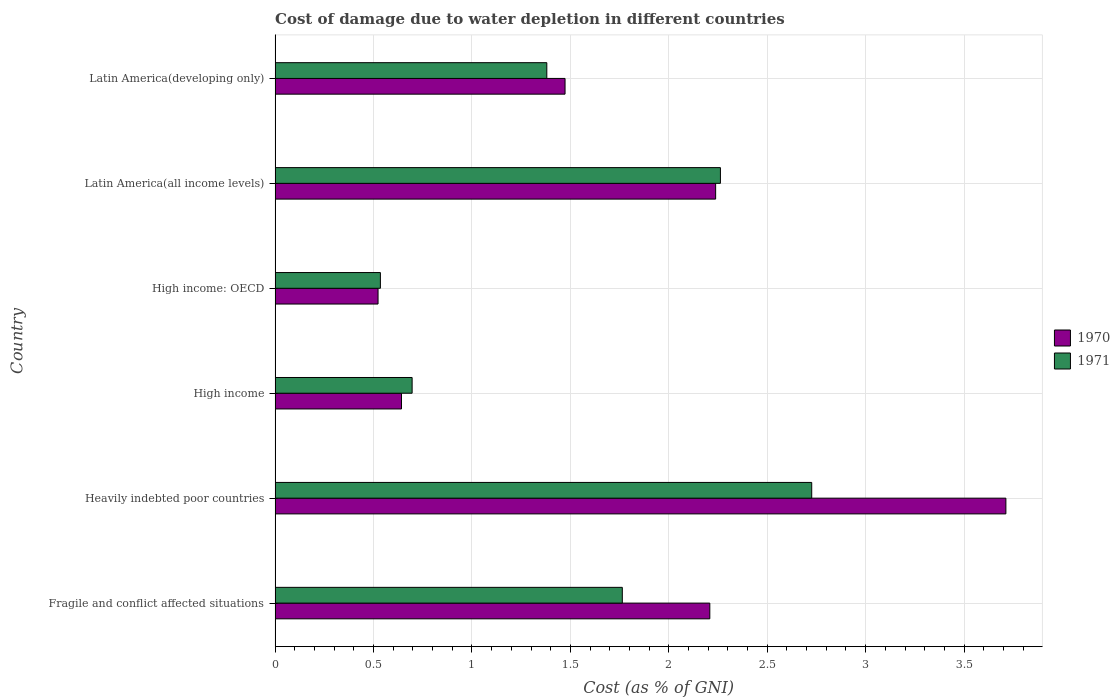How many groups of bars are there?
Make the answer very short. 6. Are the number of bars on each tick of the Y-axis equal?
Your answer should be very brief. Yes. How many bars are there on the 2nd tick from the bottom?
Offer a very short reply. 2. What is the label of the 3rd group of bars from the top?
Your answer should be very brief. High income: OECD. What is the cost of damage caused due to water depletion in 1971 in Heavily indebted poor countries?
Offer a very short reply. 2.73. Across all countries, what is the maximum cost of damage caused due to water depletion in 1971?
Provide a short and direct response. 2.73. Across all countries, what is the minimum cost of damage caused due to water depletion in 1970?
Make the answer very short. 0.52. In which country was the cost of damage caused due to water depletion in 1970 maximum?
Your response must be concise. Heavily indebted poor countries. In which country was the cost of damage caused due to water depletion in 1971 minimum?
Your answer should be compact. High income: OECD. What is the total cost of damage caused due to water depletion in 1970 in the graph?
Give a very brief answer. 10.8. What is the difference between the cost of damage caused due to water depletion in 1970 in Fragile and conflict affected situations and that in Latin America(all income levels)?
Make the answer very short. -0.03. What is the difference between the cost of damage caused due to water depletion in 1970 in Heavily indebted poor countries and the cost of damage caused due to water depletion in 1971 in Latin America(developing only)?
Your response must be concise. 2.33. What is the average cost of damage caused due to water depletion in 1971 per country?
Offer a very short reply. 1.56. What is the difference between the cost of damage caused due to water depletion in 1971 and cost of damage caused due to water depletion in 1970 in Fragile and conflict affected situations?
Offer a terse response. -0.44. In how many countries, is the cost of damage caused due to water depletion in 1971 greater than 2.9 %?
Provide a short and direct response. 0. What is the ratio of the cost of damage caused due to water depletion in 1971 in Fragile and conflict affected situations to that in High income?
Offer a terse response. 2.53. Is the cost of damage caused due to water depletion in 1970 in High income: OECD less than that in Latin America(all income levels)?
Give a very brief answer. Yes. Is the difference between the cost of damage caused due to water depletion in 1971 in Fragile and conflict affected situations and Latin America(all income levels) greater than the difference between the cost of damage caused due to water depletion in 1970 in Fragile and conflict affected situations and Latin America(all income levels)?
Ensure brevity in your answer.  No. What is the difference between the highest and the second highest cost of damage caused due to water depletion in 1970?
Keep it short and to the point. 1.47. What is the difference between the highest and the lowest cost of damage caused due to water depletion in 1971?
Provide a short and direct response. 2.19. What does the 2nd bar from the top in Latin America(developing only) represents?
Provide a short and direct response. 1970. How many bars are there?
Offer a very short reply. 12. Are all the bars in the graph horizontal?
Make the answer very short. Yes. Are the values on the major ticks of X-axis written in scientific E-notation?
Keep it short and to the point. No. Does the graph contain any zero values?
Offer a very short reply. No. Does the graph contain grids?
Provide a succinct answer. Yes. How many legend labels are there?
Provide a short and direct response. 2. What is the title of the graph?
Make the answer very short. Cost of damage due to water depletion in different countries. Does "1971" appear as one of the legend labels in the graph?
Your response must be concise. Yes. What is the label or title of the X-axis?
Provide a succinct answer. Cost (as % of GNI). What is the label or title of the Y-axis?
Your response must be concise. Country. What is the Cost (as % of GNI) of 1970 in Fragile and conflict affected situations?
Give a very brief answer. 2.21. What is the Cost (as % of GNI) of 1971 in Fragile and conflict affected situations?
Keep it short and to the point. 1.76. What is the Cost (as % of GNI) of 1970 in Heavily indebted poor countries?
Make the answer very short. 3.71. What is the Cost (as % of GNI) in 1971 in Heavily indebted poor countries?
Keep it short and to the point. 2.73. What is the Cost (as % of GNI) of 1970 in High income?
Give a very brief answer. 0.64. What is the Cost (as % of GNI) of 1971 in High income?
Provide a short and direct response. 0.7. What is the Cost (as % of GNI) of 1970 in High income: OECD?
Make the answer very short. 0.52. What is the Cost (as % of GNI) of 1971 in High income: OECD?
Make the answer very short. 0.53. What is the Cost (as % of GNI) in 1970 in Latin America(all income levels)?
Give a very brief answer. 2.24. What is the Cost (as % of GNI) in 1971 in Latin America(all income levels)?
Your response must be concise. 2.26. What is the Cost (as % of GNI) in 1970 in Latin America(developing only)?
Offer a terse response. 1.47. What is the Cost (as % of GNI) of 1971 in Latin America(developing only)?
Provide a succinct answer. 1.38. Across all countries, what is the maximum Cost (as % of GNI) in 1970?
Provide a short and direct response. 3.71. Across all countries, what is the maximum Cost (as % of GNI) of 1971?
Your response must be concise. 2.73. Across all countries, what is the minimum Cost (as % of GNI) in 1970?
Give a very brief answer. 0.52. Across all countries, what is the minimum Cost (as % of GNI) in 1971?
Ensure brevity in your answer.  0.53. What is the total Cost (as % of GNI) in 1970 in the graph?
Your answer should be very brief. 10.8. What is the total Cost (as % of GNI) in 1971 in the graph?
Keep it short and to the point. 9.36. What is the difference between the Cost (as % of GNI) of 1970 in Fragile and conflict affected situations and that in Heavily indebted poor countries?
Provide a short and direct response. -1.5. What is the difference between the Cost (as % of GNI) in 1971 in Fragile and conflict affected situations and that in Heavily indebted poor countries?
Give a very brief answer. -0.96. What is the difference between the Cost (as % of GNI) in 1970 in Fragile and conflict affected situations and that in High income?
Your answer should be very brief. 1.57. What is the difference between the Cost (as % of GNI) in 1971 in Fragile and conflict affected situations and that in High income?
Offer a very short reply. 1.07. What is the difference between the Cost (as % of GNI) in 1970 in Fragile and conflict affected situations and that in High income: OECD?
Your response must be concise. 1.69. What is the difference between the Cost (as % of GNI) of 1971 in Fragile and conflict affected situations and that in High income: OECD?
Provide a short and direct response. 1.23. What is the difference between the Cost (as % of GNI) of 1970 in Fragile and conflict affected situations and that in Latin America(all income levels)?
Offer a terse response. -0.03. What is the difference between the Cost (as % of GNI) in 1971 in Fragile and conflict affected situations and that in Latin America(all income levels)?
Ensure brevity in your answer.  -0.5. What is the difference between the Cost (as % of GNI) of 1970 in Fragile and conflict affected situations and that in Latin America(developing only)?
Provide a short and direct response. 0.74. What is the difference between the Cost (as % of GNI) in 1971 in Fragile and conflict affected situations and that in Latin America(developing only)?
Make the answer very short. 0.38. What is the difference between the Cost (as % of GNI) in 1970 in Heavily indebted poor countries and that in High income?
Your answer should be very brief. 3.07. What is the difference between the Cost (as % of GNI) of 1971 in Heavily indebted poor countries and that in High income?
Your response must be concise. 2.03. What is the difference between the Cost (as % of GNI) in 1970 in Heavily indebted poor countries and that in High income: OECD?
Provide a short and direct response. 3.19. What is the difference between the Cost (as % of GNI) in 1971 in Heavily indebted poor countries and that in High income: OECD?
Your answer should be compact. 2.19. What is the difference between the Cost (as % of GNI) of 1970 in Heavily indebted poor countries and that in Latin America(all income levels)?
Keep it short and to the point. 1.47. What is the difference between the Cost (as % of GNI) in 1971 in Heavily indebted poor countries and that in Latin America(all income levels)?
Your response must be concise. 0.46. What is the difference between the Cost (as % of GNI) in 1970 in Heavily indebted poor countries and that in Latin America(developing only)?
Ensure brevity in your answer.  2.24. What is the difference between the Cost (as % of GNI) in 1971 in Heavily indebted poor countries and that in Latin America(developing only)?
Give a very brief answer. 1.35. What is the difference between the Cost (as % of GNI) of 1970 in High income and that in High income: OECD?
Keep it short and to the point. 0.12. What is the difference between the Cost (as % of GNI) in 1971 in High income and that in High income: OECD?
Provide a succinct answer. 0.16. What is the difference between the Cost (as % of GNI) of 1970 in High income and that in Latin America(all income levels)?
Your response must be concise. -1.6. What is the difference between the Cost (as % of GNI) in 1971 in High income and that in Latin America(all income levels)?
Your answer should be compact. -1.57. What is the difference between the Cost (as % of GNI) of 1970 in High income and that in Latin America(developing only)?
Provide a short and direct response. -0.83. What is the difference between the Cost (as % of GNI) in 1971 in High income and that in Latin America(developing only)?
Your response must be concise. -0.68. What is the difference between the Cost (as % of GNI) of 1970 in High income: OECD and that in Latin America(all income levels)?
Your answer should be very brief. -1.71. What is the difference between the Cost (as % of GNI) in 1971 in High income: OECD and that in Latin America(all income levels)?
Offer a very short reply. -1.73. What is the difference between the Cost (as % of GNI) in 1970 in High income: OECD and that in Latin America(developing only)?
Offer a very short reply. -0.95. What is the difference between the Cost (as % of GNI) of 1971 in High income: OECD and that in Latin America(developing only)?
Offer a terse response. -0.85. What is the difference between the Cost (as % of GNI) of 1970 in Latin America(all income levels) and that in Latin America(developing only)?
Ensure brevity in your answer.  0.76. What is the difference between the Cost (as % of GNI) of 1971 in Latin America(all income levels) and that in Latin America(developing only)?
Offer a terse response. 0.88. What is the difference between the Cost (as % of GNI) in 1970 in Fragile and conflict affected situations and the Cost (as % of GNI) in 1971 in Heavily indebted poor countries?
Provide a short and direct response. -0.52. What is the difference between the Cost (as % of GNI) in 1970 in Fragile and conflict affected situations and the Cost (as % of GNI) in 1971 in High income?
Keep it short and to the point. 1.51. What is the difference between the Cost (as % of GNI) in 1970 in Fragile and conflict affected situations and the Cost (as % of GNI) in 1971 in High income: OECD?
Offer a very short reply. 1.67. What is the difference between the Cost (as % of GNI) of 1970 in Fragile and conflict affected situations and the Cost (as % of GNI) of 1971 in Latin America(all income levels)?
Your answer should be compact. -0.05. What is the difference between the Cost (as % of GNI) in 1970 in Fragile and conflict affected situations and the Cost (as % of GNI) in 1971 in Latin America(developing only)?
Keep it short and to the point. 0.83. What is the difference between the Cost (as % of GNI) of 1970 in Heavily indebted poor countries and the Cost (as % of GNI) of 1971 in High income?
Your answer should be very brief. 3.02. What is the difference between the Cost (as % of GNI) of 1970 in Heavily indebted poor countries and the Cost (as % of GNI) of 1971 in High income: OECD?
Provide a short and direct response. 3.18. What is the difference between the Cost (as % of GNI) of 1970 in Heavily indebted poor countries and the Cost (as % of GNI) of 1971 in Latin America(all income levels)?
Offer a very short reply. 1.45. What is the difference between the Cost (as % of GNI) in 1970 in Heavily indebted poor countries and the Cost (as % of GNI) in 1971 in Latin America(developing only)?
Offer a terse response. 2.33. What is the difference between the Cost (as % of GNI) of 1970 in High income and the Cost (as % of GNI) of 1971 in High income: OECD?
Your answer should be compact. 0.11. What is the difference between the Cost (as % of GNI) of 1970 in High income and the Cost (as % of GNI) of 1971 in Latin America(all income levels)?
Offer a terse response. -1.62. What is the difference between the Cost (as % of GNI) in 1970 in High income and the Cost (as % of GNI) in 1971 in Latin America(developing only)?
Keep it short and to the point. -0.74. What is the difference between the Cost (as % of GNI) of 1970 in High income: OECD and the Cost (as % of GNI) of 1971 in Latin America(all income levels)?
Your answer should be compact. -1.74. What is the difference between the Cost (as % of GNI) in 1970 in High income: OECD and the Cost (as % of GNI) in 1971 in Latin America(developing only)?
Your answer should be very brief. -0.86. What is the difference between the Cost (as % of GNI) of 1970 in Latin America(all income levels) and the Cost (as % of GNI) of 1971 in Latin America(developing only)?
Your answer should be very brief. 0.86. What is the average Cost (as % of GNI) of 1970 per country?
Your answer should be very brief. 1.8. What is the average Cost (as % of GNI) in 1971 per country?
Provide a succinct answer. 1.56. What is the difference between the Cost (as % of GNI) of 1970 and Cost (as % of GNI) of 1971 in Fragile and conflict affected situations?
Provide a succinct answer. 0.44. What is the difference between the Cost (as % of GNI) in 1970 and Cost (as % of GNI) in 1971 in Heavily indebted poor countries?
Give a very brief answer. 0.99. What is the difference between the Cost (as % of GNI) in 1970 and Cost (as % of GNI) in 1971 in High income?
Offer a very short reply. -0.05. What is the difference between the Cost (as % of GNI) in 1970 and Cost (as % of GNI) in 1971 in High income: OECD?
Your answer should be very brief. -0.01. What is the difference between the Cost (as % of GNI) of 1970 and Cost (as % of GNI) of 1971 in Latin America(all income levels)?
Keep it short and to the point. -0.02. What is the difference between the Cost (as % of GNI) of 1970 and Cost (as % of GNI) of 1971 in Latin America(developing only)?
Provide a succinct answer. 0.09. What is the ratio of the Cost (as % of GNI) in 1970 in Fragile and conflict affected situations to that in Heavily indebted poor countries?
Provide a short and direct response. 0.59. What is the ratio of the Cost (as % of GNI) of 1971 in Fragile and conflict affected situations to that in Heavily indebted poor countries?
Offer a terse response. 0.65. What is the ratio of the Cost (as % of GNI) in 1970 in Fragile and conflict affected situations to that in High income?
Provide a short and direct response. 3.44. What is the ratio of the Cost (as % of GNI) in 1971 in Fragile and conflict affected situations to that in High income?
Give a very brief answer. 2.53. What is the ratio of the Cost (as % of GNI) of 1970 in Fragile and conflict affected situations to that in High income: OECD?
Keep it short and to the point. 4.22. What is the ratio of the Cost (as % of GNI) in 1971 in Fragile and conflict affected situations to that in High income: OECD?
Give a very brief answer. 3.3. What is the ratio of the Cost (as % of GNI) in 1970 in Fragile and conflict affected situations to that in Latin America(all income levels)?
Your answer should be compact. 0.99. What is the ratio of the Cost (as % of GNI) in 1971 in Fragile and conflict affected situations to that in Latin America(all income levels)?
Provide a succinct answer. 0.78. What is the ratio of the Cost (as % of GNI) of 1970 in Fragile and conflict affected situations to that in Latin America(developing only)?
Offer a very short reply. 1.5. What is the ratio of the Cost (as % of GNI) in 1971 in Fragile and conflict affected situations to that in Latin America(developing only)?
Provide a short and direct response. 1.28. What is the ratio of the Cost (as % of GNI) of 1970 in Heavily indebted poor countries to that in High income?
Ensure brevity in your answer.  5.78. What is the ratio of the Cost (as % of GNI) in 1971 in Heavily indebted poor countries to that in High income?
Your answer should be very brief. 3.92. What is the ratio of the Cost (as % of GNI) of 1970 in Heavily indebted poor countries to that in High income: OECD?
Your answer should be very brief. 7.1. What is the ratio of the Cost (as % of GNI) of 1971 in Heavily indebted poor countries to that in High income: OECD?
Make the answer very short. 5.1. What is the ratio of the Cost (as % of GNI) in 1970 in Heavily indebted poor countries to that in Latin America(all income levels)?
Your response must be concise. 1.66. What is the ratio of the Cost (as % of GNI) of 1971 in Heavily indebted poor countries to that in Latin America(all income levels)?
Give a very brief answer. 1.21. What is the ratio of the Cost (as % of GNI) of 1970 in Heavily indebted poor countries to that in Latin America(developing only)?
Provide a short and direct response. 2.52. What is the ratio of the Cost (as % of GNI) of 1971 in Heavily indebted poor countries to that in Latin America(developing only)?
Make the answer very short. 1.97. What is the ratio of the Cost (as % of GNI) in 1970 in High income to that in High income: OECD?
Your answer should be compact. 1.23. What is the ratio of the Cost (as % of GNI) in 1971 in High income to that in High income: OECD?
Provide a short and direct response. 1.3. What is the ratio of the Cost (as % of GNI) in 1970 in High income to that in Latin America(all income levels)?
Provide a succinct answer. 0.29. What is the ratio of the Cost (as % of GNI) of 1971 in High income to that in Latin America(all income levels)?
Provide a short and direct response. 0.31. What is the ratio of the Cost (as % of GNI) in 1970 in High income to that in Latin America(developing only)?
Provide a succinct answer. 0.44. What is the ratio of the Cost (as % of GNI) in 1971 in High income to that in Latin America(developing only)?
Offer a very short reply. 0.5. What is the ratio of the Cost (as % of GNI) in 1970 in High income: OECD to that in Latin America(all income levels)?
Your answer should be compact. 0.23. What is the ratio of the Cost (as % of GNI) of 1971 in High income: OECD to that in Latin America(all income levels)?
Your response must be concise. 0.24. What is the ratio of the Cost (as % of GNI) of 1970 in High income: OECD to that in Latin America(developing only)?
Offer a very short reply. 0.36. What is the ratio of the Cost (as % of GNI) of 1971 in High income: OECD to that in Latin America(developing only)?
Your answer should be compact. 0.39. What is the ratio of the Cost (as % of GNI) of 1970 in Latin America(all income levels) to that in Latin America(developing only)?
Provide a short and direct response. 1.52. What is the ratio of the Cost (as % of GNI) in 1971 in Latin America(all income levels) to that in Latin America(developing only)?
Your response must be concise. 1.64. What is the difference between the highest and the second highest Cost (as % of GNI) in 1970?
Provide a succinct answer. 1.47. What is the difference between the highest and the second highest Cost (as % of GNI) of 1971?
Make the answer very short. 0.46. What is the difference between the highest and the lowest Cost (as % of GNI) in 1970?
Offer a terse response. 3.19. What is the difference between the highest and the lowest Cost (as % of GNI) in 1971?
Make the answer very short. 2.19. 